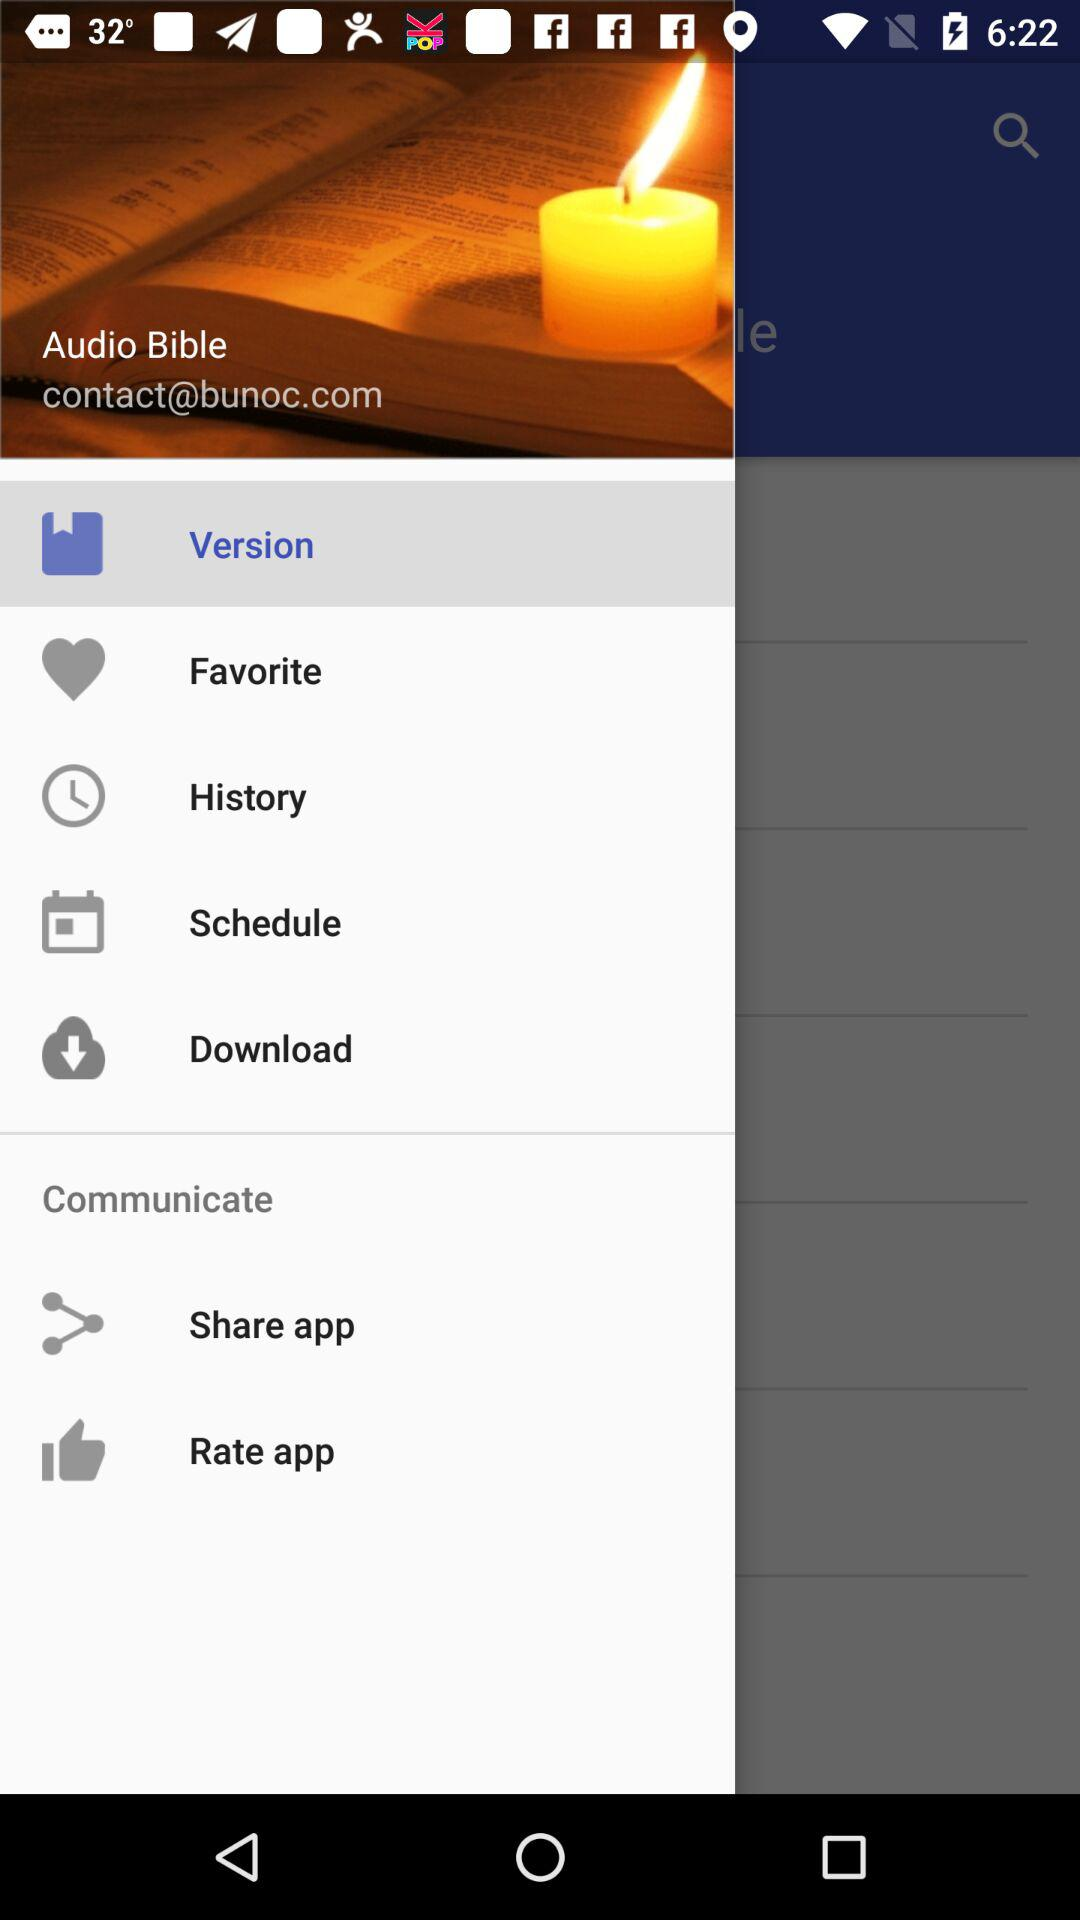What is the email address? The email address is contact@bunoc.com. 